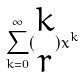Convert formula to latex. <formula><loc_0><loc_0><loc_500><loc_500>\sum _ { k = 0 } ^ { \infty } ( \begin{matrix} k \\ r \end{matrix} ) x ^ { k }</formula> 